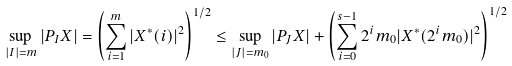Convert formula to latex. <formula><loc_0><loc_0><loc_500><loc_500>\sup _ { | I | = m } | P _ { I } X | = \left ( \sum _ { i = 1 } ^ { m } | X ^ { * } ( i ) | ^ { 2 } \right ) ^ { 1 / 2 } \leq \sup _ { | J | = m _ { 0 } } | P _ { J } X | + \left ( \sum _ { i = 0 } ^ { s - 1 } 2 ^ { i } m _ { 0 } | X ^ { * } ( 2 ^ { i } m _ { 0 } ) | ^ { 2 } \right ) ^ { 1 / 2 }</formula> 